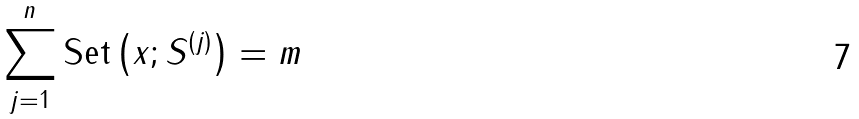Convert formula to latex. <formula><loc_0><loc_0><loc_500><loc_500>\sum _ { j = 1 } ^ { n } \text {Set} \left ( x ; S ^ { ( j ) } \right ) = m</formula> 